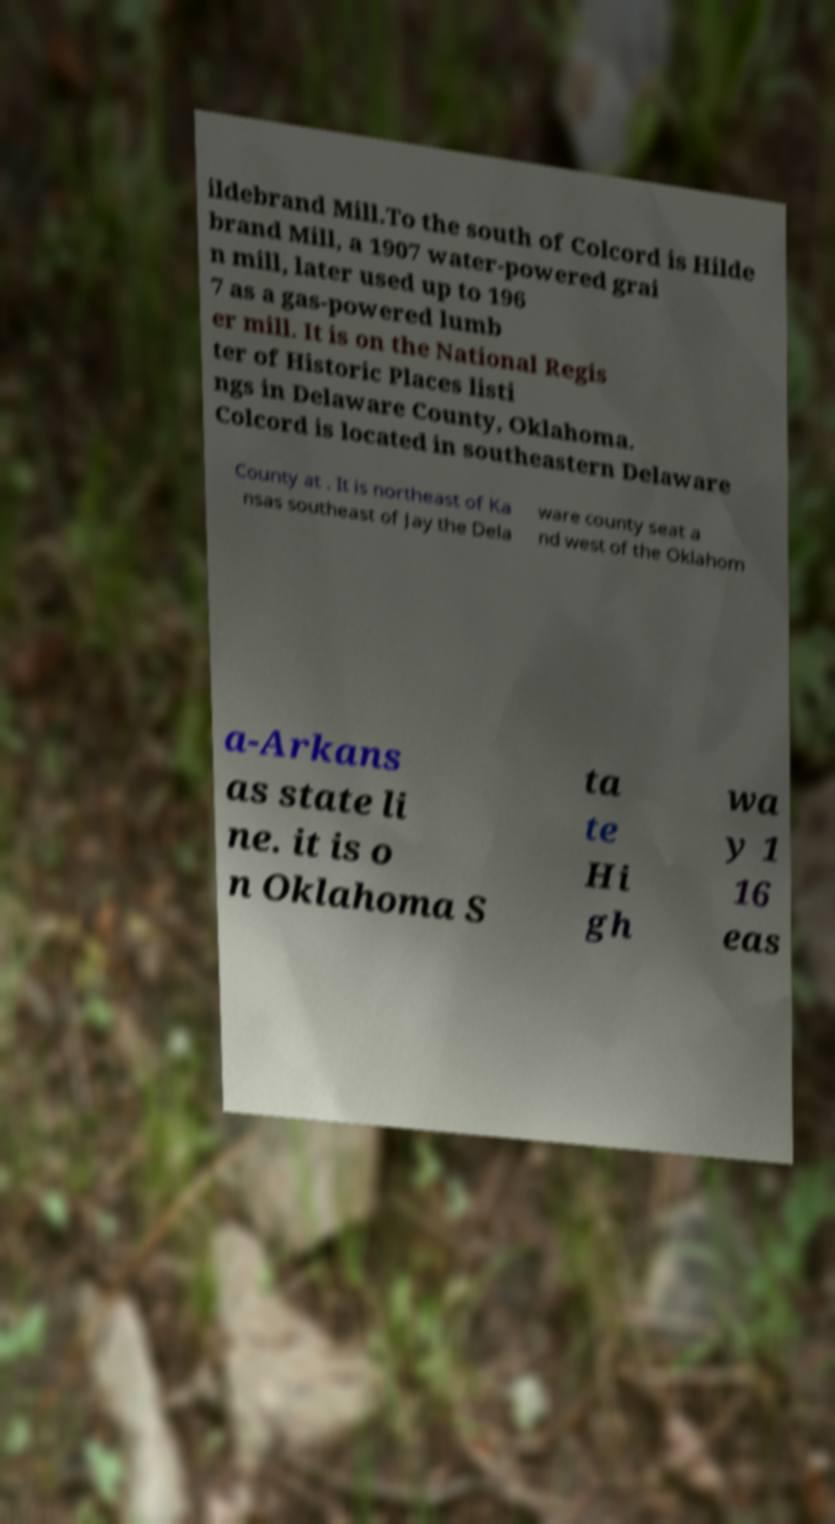Could you extract and type out the text from this image? ildebrand Mill.To the south of Colcord is Hilde brand Mill, a 1907 water-powered grai n mill, later used up to 196 7 as a gas-powered lumb er mill. It is on the National Regis ter of Historic Places listi ngs in Delaware County, Oklahoma. Colcord is located in southeastern Delaware County at . It is northeast of Ka nsas southeast of Jay the Dela ware county seat a nd west of the Oklahom a-Arkans as state li ne. it is o n Oklahoma S ta te Hi gh wa y 1 16 eas 